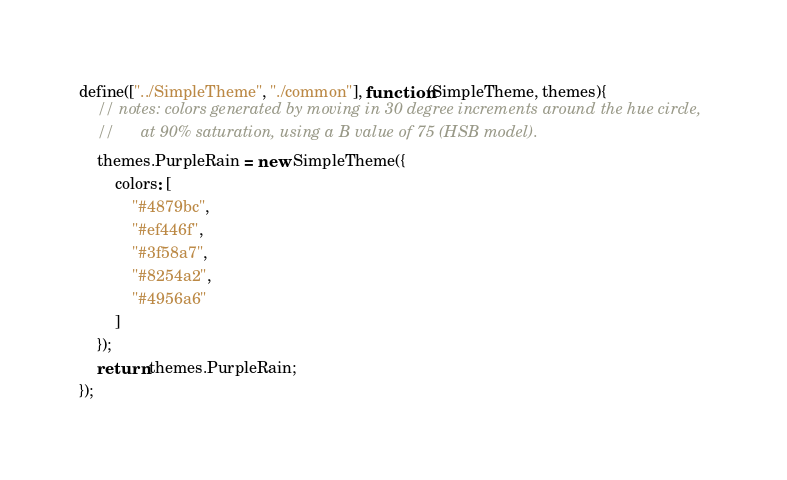<code> <loc_0><loc_0><loc_500><loc_500><_JavaScript_>define(["../SimpleTheme", "./common"], function(SimpleTheme, themes){
	// notes: colors generated by moving in 30 degree increments around the hue circle,
	//		at 90% saturation, using a B value of 75 (HSB model).
	themes.PurpleRain = new SimpleTheme({
		colors: [
			"#4879bc",
			"#ef446f",
			"#3f58a7",
			"#8254a2",
			"#4956a6"
		]
	});
	return themes.PurpleRain;
});
</code> 